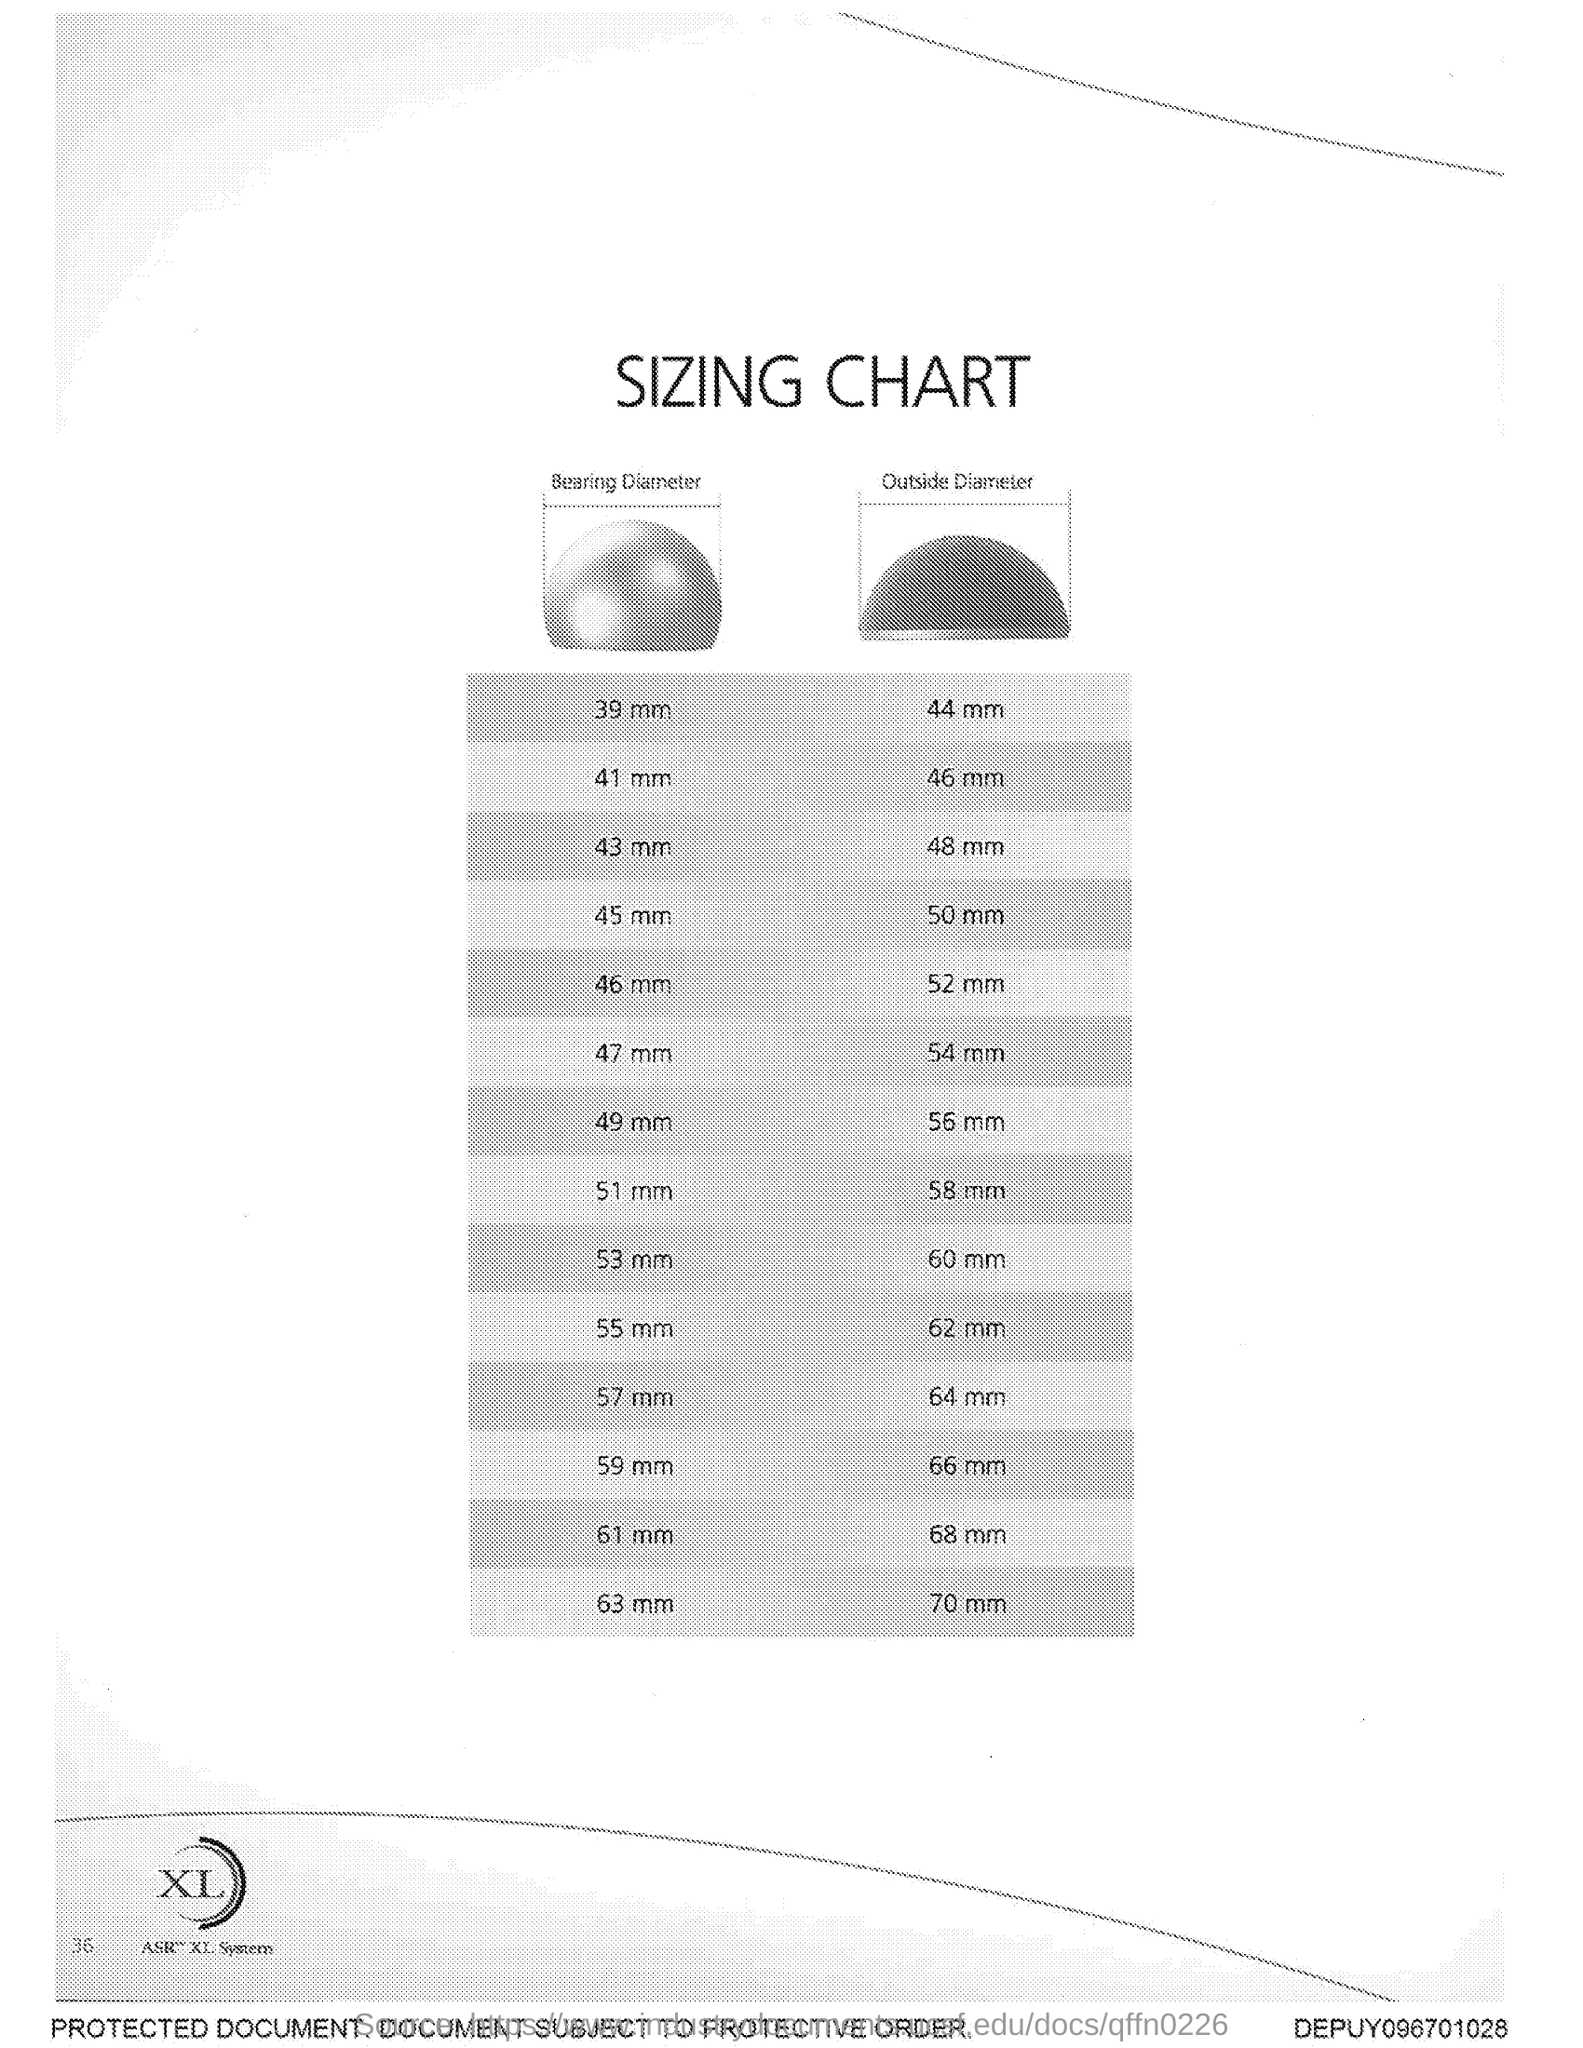Mention a couple of crucial points in this snapshot. The title of the document is a sizing chart. 